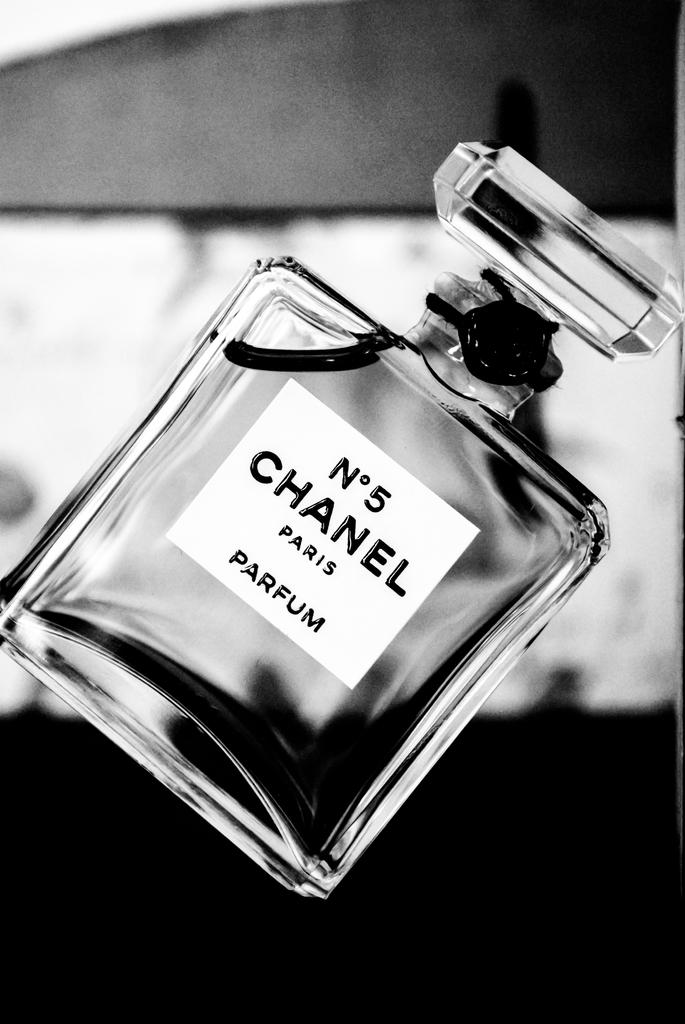What city is on the perfume bottle?
Keep it short and to the point. Paris. 